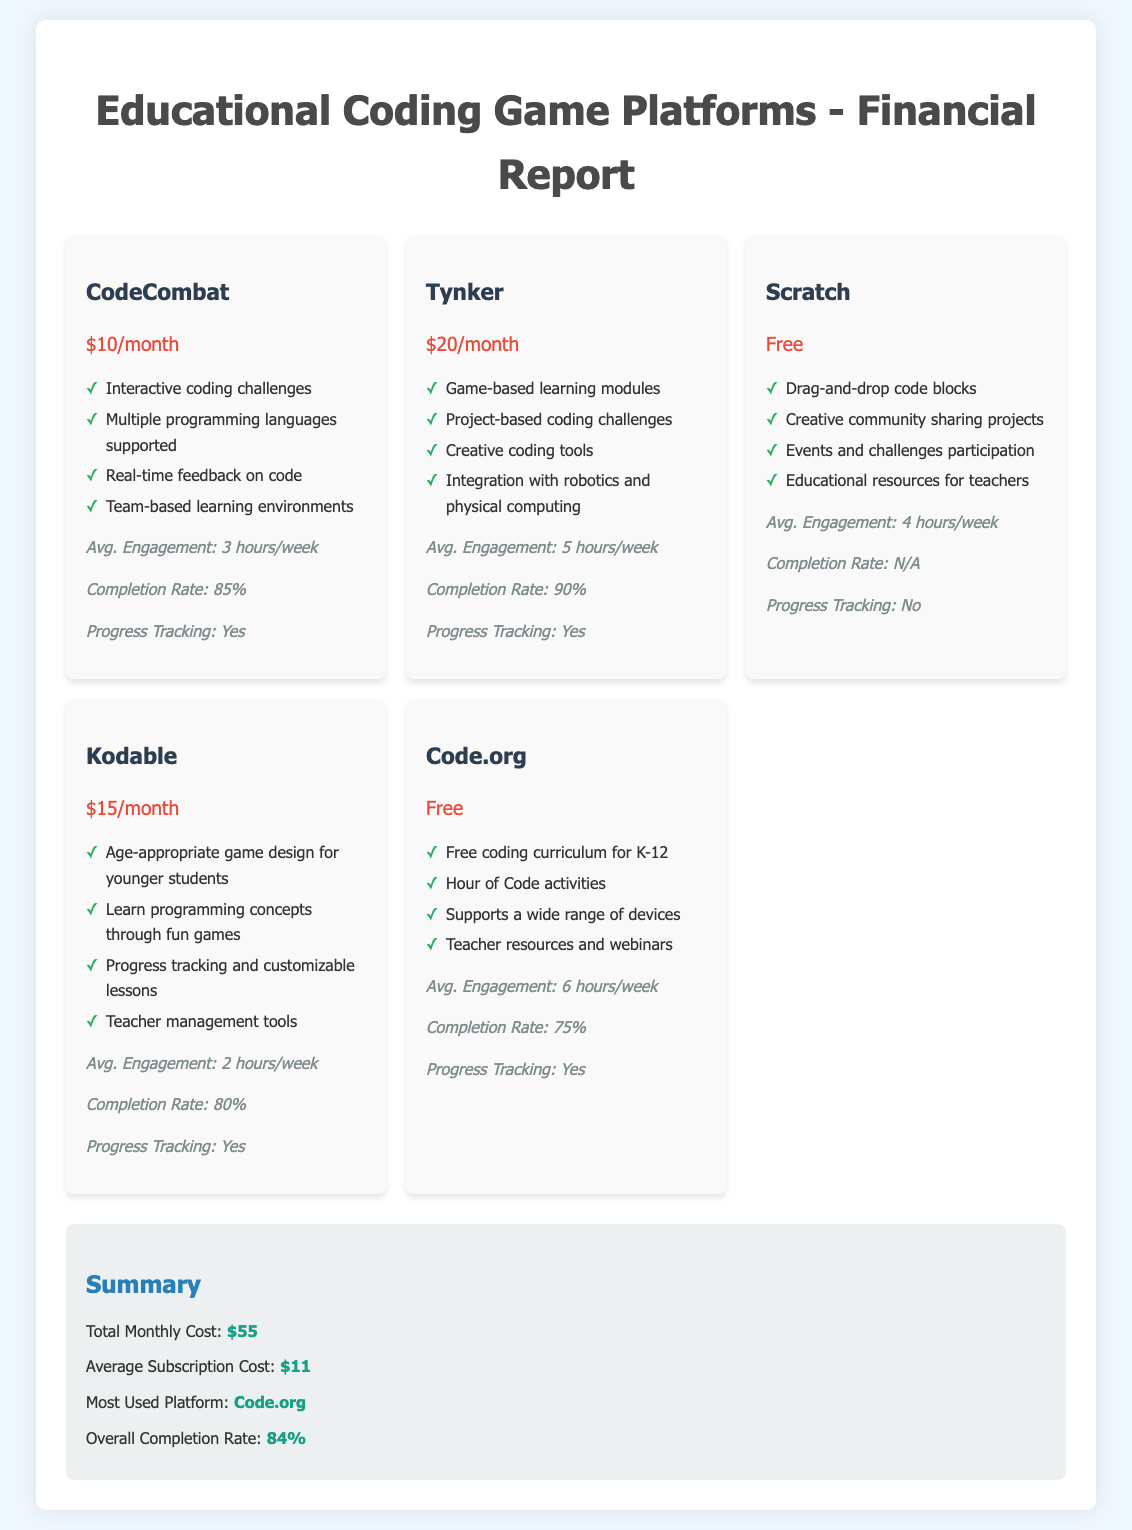what is the monthly cost of CodeCombat? The monthly cost of CodeCombat is explicitly stated in the document.
Answer: $10/month what features does Tynker offer? The features of Tynker are listed and can be retrieved directly from the document.
Answer: Game-based learning modules, Project-based coding challenges, Creative coding tools, Integration with robotics and physical computing what is the Avg. Engagement for Scratch? The Avg. Engagement for Scratch is provided in the analytics section of its card.
Answer: 4 hours/week which platform has the highest completion rate? By comparing the completion rates listed for each platform, we can identify which one is the highest.
Answer: Tynker how much is the total monthly cost for all platforms? The total monthly cost is summarized in the document and refers to the sum of the subscription costs.
Answer: $55 what is the most used platform according to the summary? The summary section indicates the most used platform based on user engagement data.
Answer: Code.org what is the pricing model of Scratch? Scratch's pricing model is mentioned in the document, indicating its availability.
Answer: Free which platform provides progress tracking? The document specifies which platforms have progress tracking features as part of their analytics.
Answer: CodeCombat, Tynker, Kodable, Code.org what percentage is the overall completion rate? The overall completion rate is summarized at the end of the document in the summary section.
Answer: 84% 